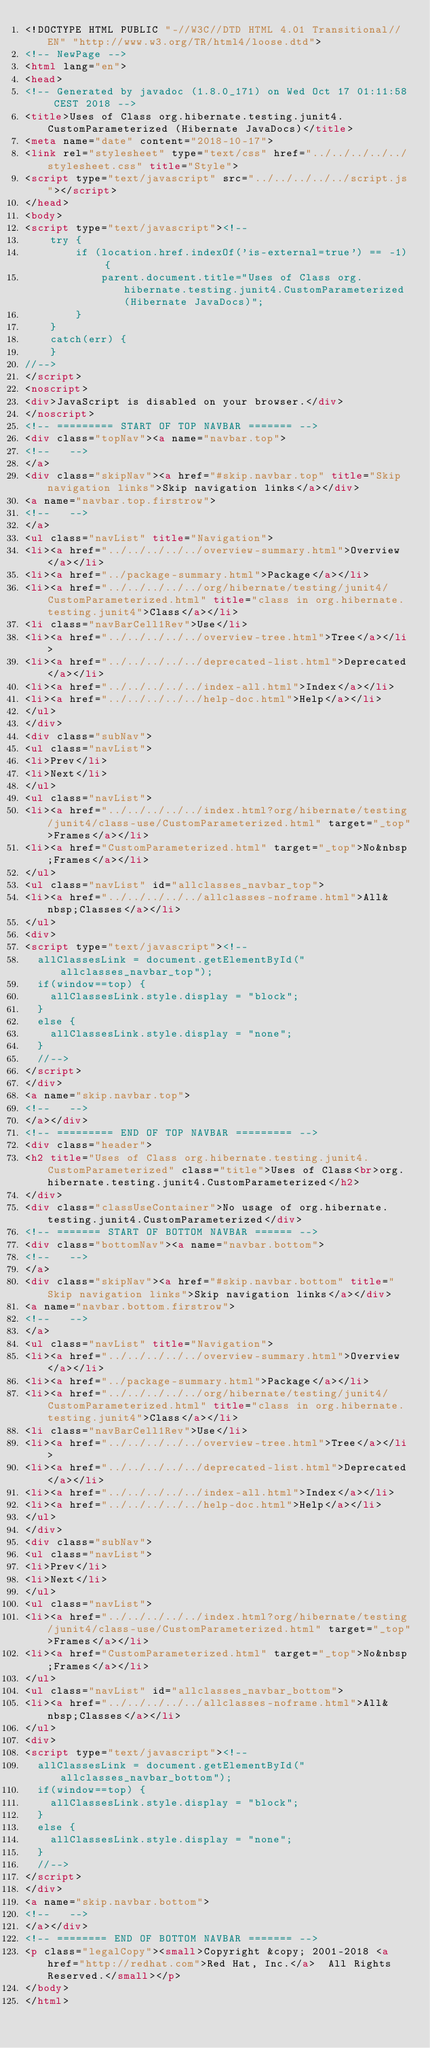<code> <loc_0><loc_0><loc_500><loc_500><_HTML_><!DOCTYPE HTML PUBLIC "-//W3C//DTD HTML 4.01 Transitional//EN" "http://www.w3.org/TR/html4/loose.dtd">
<!-- NewPage -->
<html lang="en">
<head>
<!-- Generated by javadoc (1.8.0_171) on Wed Oct 17 01:11:58 CEST 2018 -->
<title>Uses of Class org.hibernate.testing.junit4.CustomParameterized (Hibernate JavaDocs)</title>
<meta name="date" content="2018-10-17">
<link rel="stylesheet" type="text/css" href="../../../../../stylesheet.css" title="Style">
<script type="text/javascript" src="../../../../../script.js"></script>
</head>
<body>
<script type="text/javascript"><!--
    try {
        if (location.href.indexOf('is-external=true') == -1) {
            parent.document.title="Uses of Class org.hibernate.testing.junit4.CustomParameterized (Hibernate JavaDocs)";
        }
    }
    catch(err) {
    }
//-->
</script>
<noscript>
<div>JavaScript is disabled on your browser.</div>
</noscript>
<!-- ========= START OF TOP NAVBAR ======= -->
<div class="topNav"><a name="navbar.top">
<!--   -->
</a>
<div class="skipNav"><a href="#skip.navbar.top" title="Skip navigation links">Skip navigation links</a></div>
<a name="navbar.top.firstrow">
<!--   -->
</a>
<ul class="navList" title="Navigation">
<li><a href="../../../../../overview-summary.html">Overview</a></li>
<li><a href="../package-summary.html">Package</a></li>
<li><a href="../../../../../org/hibernate/testing/junit4/CustomParameterized.html" title="class in org.hibernate.testing.junit4">Class</a></li>
<li class="navBarCell1Rev">Use</li>
<li><a href="../../../../../overview-tree.html">Tree</a></li>
<li><a href="../../../../../deprecated-list.html">Deprecated</a></li>
<li><a href="../../../../../index-all.html">Index</a></li>
<li><a href="../../../../../help-doc.html">Help</a></li>
</ul>
</div>
<div class="subNav">
<ul class="navList">
<li>Prev</li>
<li>Next</li>
</ul>
<ul class="navList">
<li><a href="../../../../../index.html?org/hibernate/testing/junit4/class-use/CustomParameterized.html" target="_top">Frames</a></li>
<li><a href="CustomParameterized.html" target="_top">No&nbsp;Frames</a></li>
</ul>
<ul class="navList" id="allclasses_navbar_top">
<li><a href="../../../../../allclasses-noframe.html">All&nbsp;Classes</a></li>
</ul>
<div>
<script type="text/javascript"><!--
  allClassesLink = document.getElementById("allclasses_navbar_top");
  if(window==top) {
    allClassesLink.style.display = "block";
  }
  else {
    allClassesLink.style.display = "none";
  }
  //-->
</script>
</div>
<a name="skip.navbar.top">
<!--   -->
</a></div>
<!-- ========= END OF TOP NAVBAR ========= -->
<div class="header">
<h2 title="Uses of Class org.hibernate.testing.junit4.CustomParameterized" class="title">Uses of Class<br>org.hibernate.testing.junit4.CustomParameterized</h2>
</div>
<div class="classUseContainer">No usage of org.hibernate.testing.junit4.CustomParameterized</div>
<!-- ======= START OF BOTTOM NAVBAR ====== -->
<div class="bottomNav"><a name="navbar.bottom">
<!--   -->
</a>
<div class="skipNav"><a href="#skip.navbar.bottom" title="Skip navigation links">Skip navigation links</a></div>
<a name="navbar.bottom.firstrow">
<!--   -->
</a>
<ul class="navList" title="Navigation">
<li><a href="../../../../../overview-summary.html">Overview</a></li>
<li><a href="../package-summary.html">Package</a></li>
<li><a href="../../../../../org/hibernate/testing/junit4/CustomParameterized.html" title="class in org.hibernate.testing.junit4">Class</a></li>
<li class="navBarCell1Rev">Use</li>
<li><a href="../../../../../overview-tree.html">Tree</a></li>
<li><a href="../../../../../deprecated-list.html">Deprecated</a></li>
<li><a href="../../../../../index-all.html">Index</a></li>
<li><a href="../../../../../help-doc.html">Help</a></li>
</ul>
</div>
<div class="subNav">
<ul class="navList">
<li>Prev</li>
<li>Next</li>
</ul>
<ul class="navList">
<li><a href="../../../../../index.html?org/hibernate/testing/junit4/class-use/CustomParameterized.html" target="_top">Frames</a></li>
<li><a href="CustomParameterized.html" target="_top">No&nbsp;Frames</a></li>
</ul>
<ul class="navList" id="allclasses_navbar_bottom">
<li><a href="../../../../../allclasses-noframe.html">All&nbsp;Classes</a></li>
</ul>
<div>
<script type="text/javascript"><!--
  allClassesLink = document.getElementById("allclasses_navbar_bottom");
  if(window==top) {
    allClassesLink.style.display = "block";
  }
  else {
    allClassesLink.style.display = "none";
  }
  //-->
</script>
</div>
<a name="skip.navbar.bottom">
<!--   -->
</a></div>
<!-- ======== END OF BOTTOM NAVBAR ======= -->
<p class="legalCopy"><small>Copyright &copy; 2001-2018 <a href="http://redhat.com">Red Hat, Inc.</a>  All Rights Reserved.</small></p>
</body>
</html>
</code> 